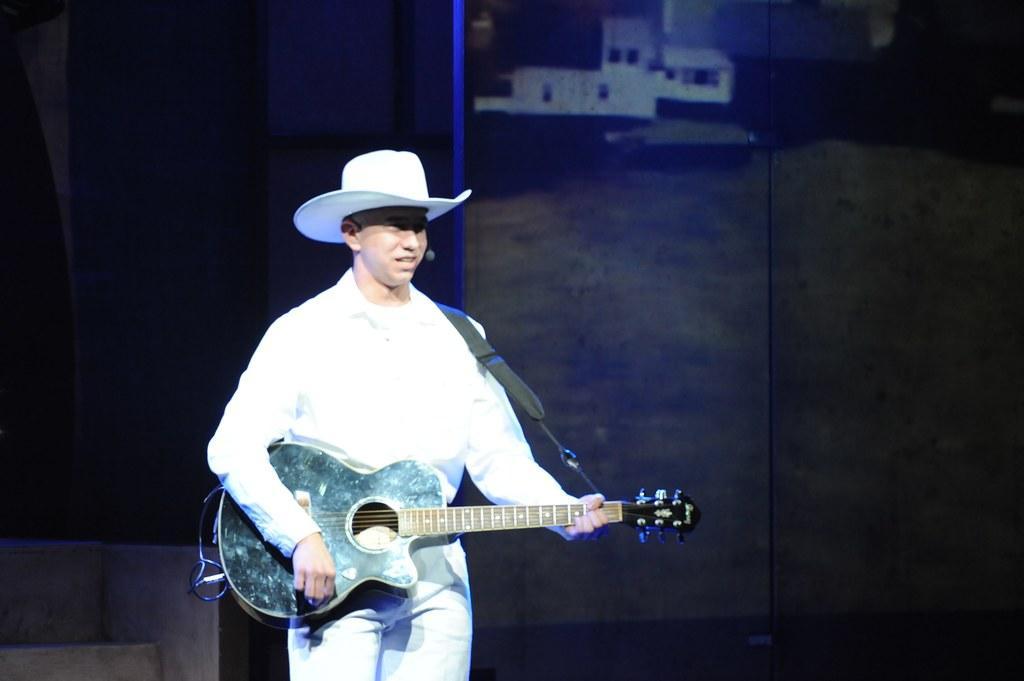Can you describe this image briefly? The image contains one person is playing the guitar and wearing some white shirt,pant and hat and background is little dark. 